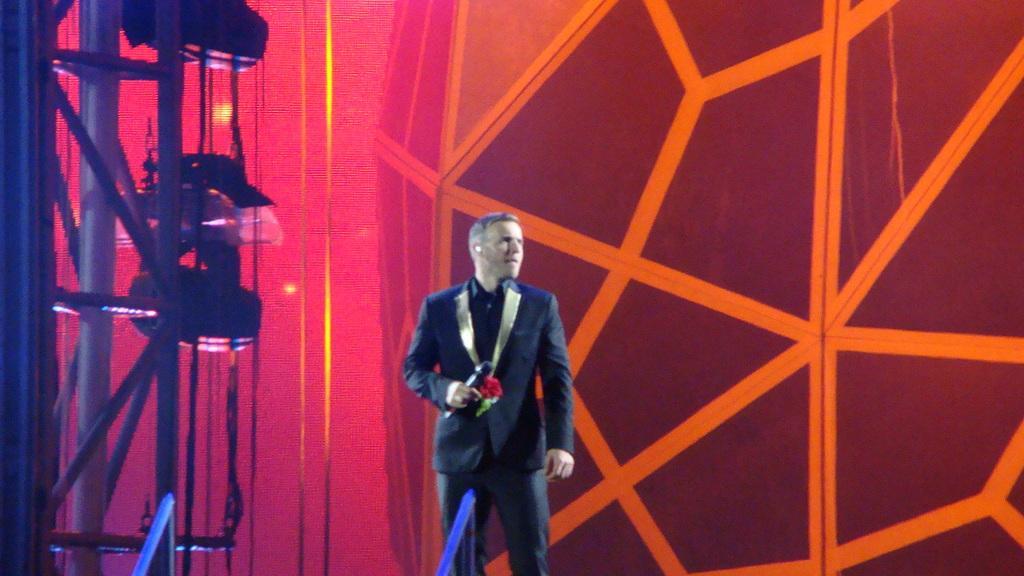How would you summarize this image in a sentence or two? In this image there is a person standing and holding a mic and flowers in his hand and he is looking right side of the image, behind him there is a metal structure and on the left side of the image there is a metal structure and some objects on it. 